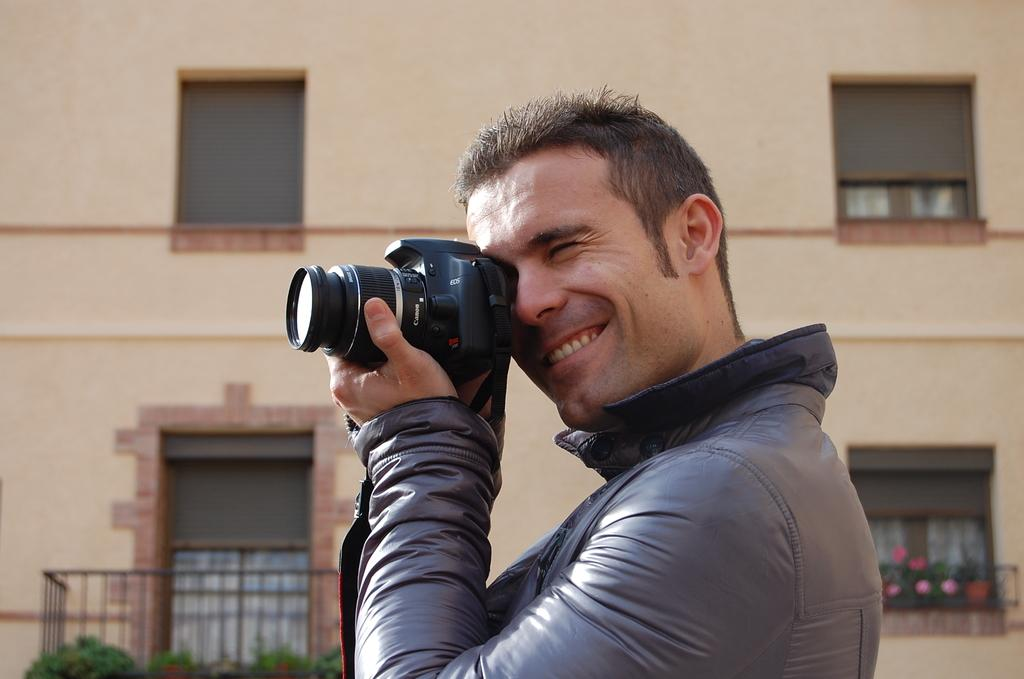Who is the main subject in the image? There is a man in the image. What is the man wearing? The man is wearing a black jacket. What is the man holding in his hands? The man is holding a camera in his hands. What is the man doing with the camera? The man is clicking images with the camera. What can be seen in the background of the image? There is a building with windows visible in the image. What type of plants can be seen growing on the man's jacket in the image? There are no plants visible on the man's jacket in the image. 